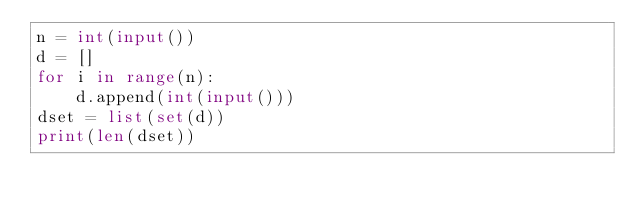Convert code to text. <code><loc_0><loc_0><loc_500><loc_500><_Python_>n = int(input())
d = []
for i in range(n):
    d.append(int(input()))
dset = list(set(d))
print(len(dset))
</code> 